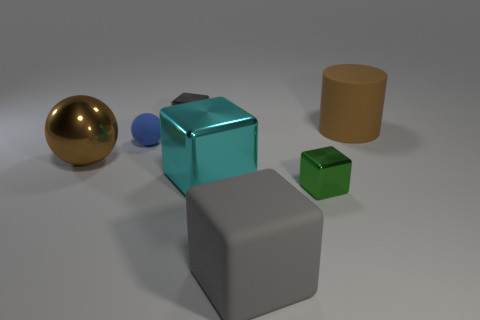What is the size of the blue sphere?
Provide a succinct answer. Small. What number of large matte things are behind the large cyan metallic block?
Make the answer very short. 1. What is the size of the matte object that is the same shape as the tiny green metal thing?
Make the answer very short. Large. What is the size of the shiny block that is in front of the large rubber cylinder and on the left side of the large gray block?
Your answer should be compact. Large. Does the rubber cube have the same color as the large object that is right of the green block?
Keep it short and to the point. No. What number of purple things are either small cubes or blocks?
Offer a terse response. 0. What shape is the tiny green object?
Provide a succinct answer. Cube. How many other things are the same shape as the brown metallic object?
Give a very brief answer. 1. There is a tiny metallic object that is behind the tiny matte ball; what color is it?
Provide a short and direct response. Gray. Are the small gray block and the big cyan thing made of the same material?
Ensure brevity in your answer.  Yes. 